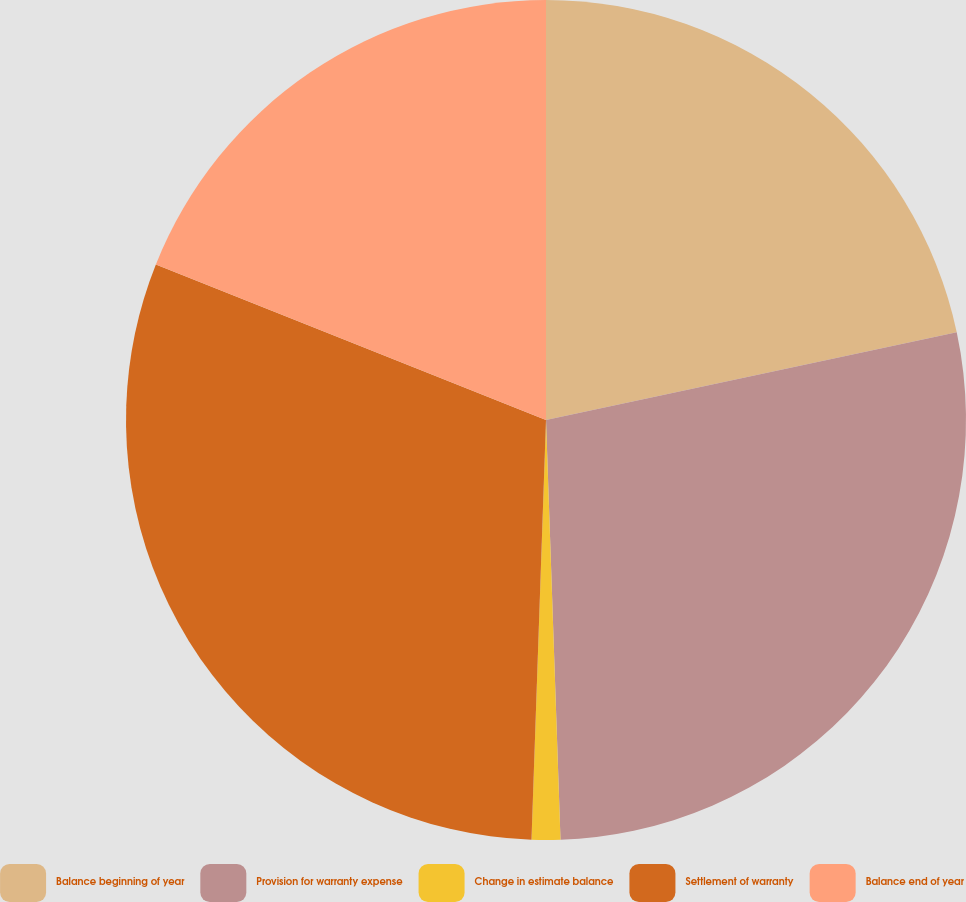<chart> <loc_0><loc_0><loc_500><loc_500><pie_chart><fcel>Balance beginning of year<fcel>Provision for warranty expense<fcel>Change in estimate balance<fcel>Settlement of warranty<fcel>Balance end of year<nl><fcel>21.65%<fcel>27.8%<fcel>1.1%<fcel>30.49%<fcel>18.96%<nl></chart> 